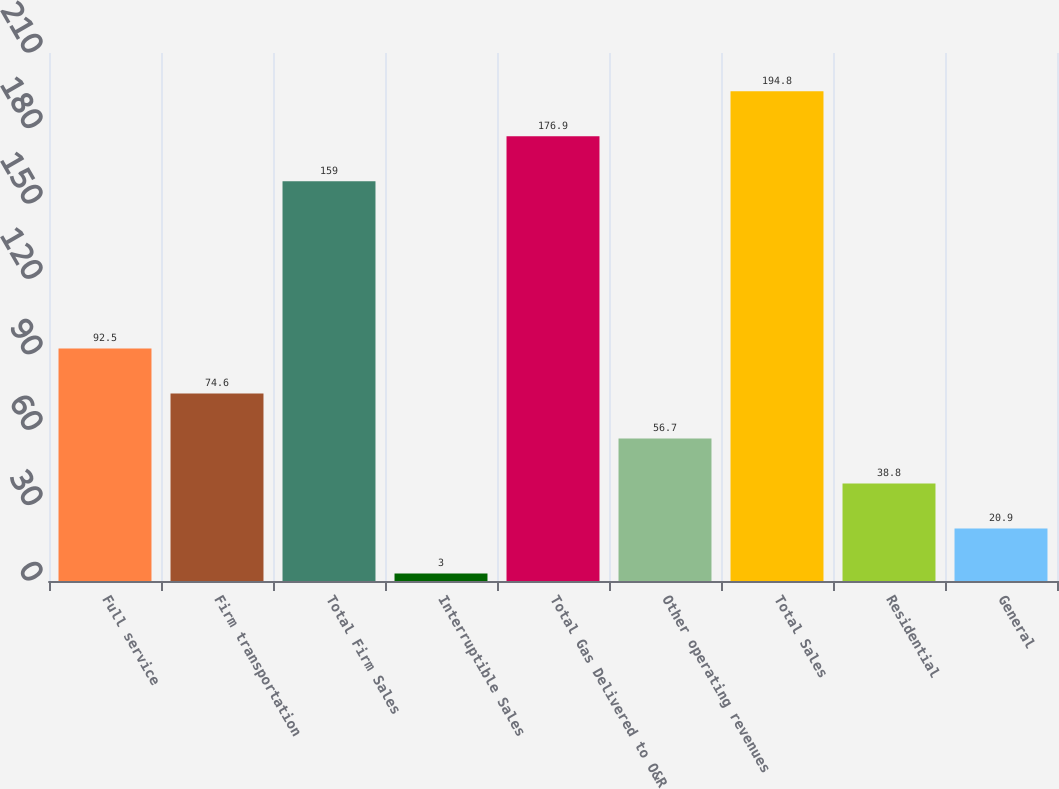Convert chart. <chart><loc_0><loc_0><loc_500><loc_500><bar_chart><fcel>Full service<fcel>Firm transportation<fcel>Total Firm Sales<fcel>Interruptible Sales<fcel>Total Gas Delivered to O&R<fcel>Other operating revenues<fcel>Total Sales<fcel>Residential<fcel>General<nl><fcel>92.5<fcel>74.6<fcel>159<fcel>3<fcel>176.9<fcel>56.7<fcel>194.8<fcel>38.8<fcel>20.9<nl></chart> 